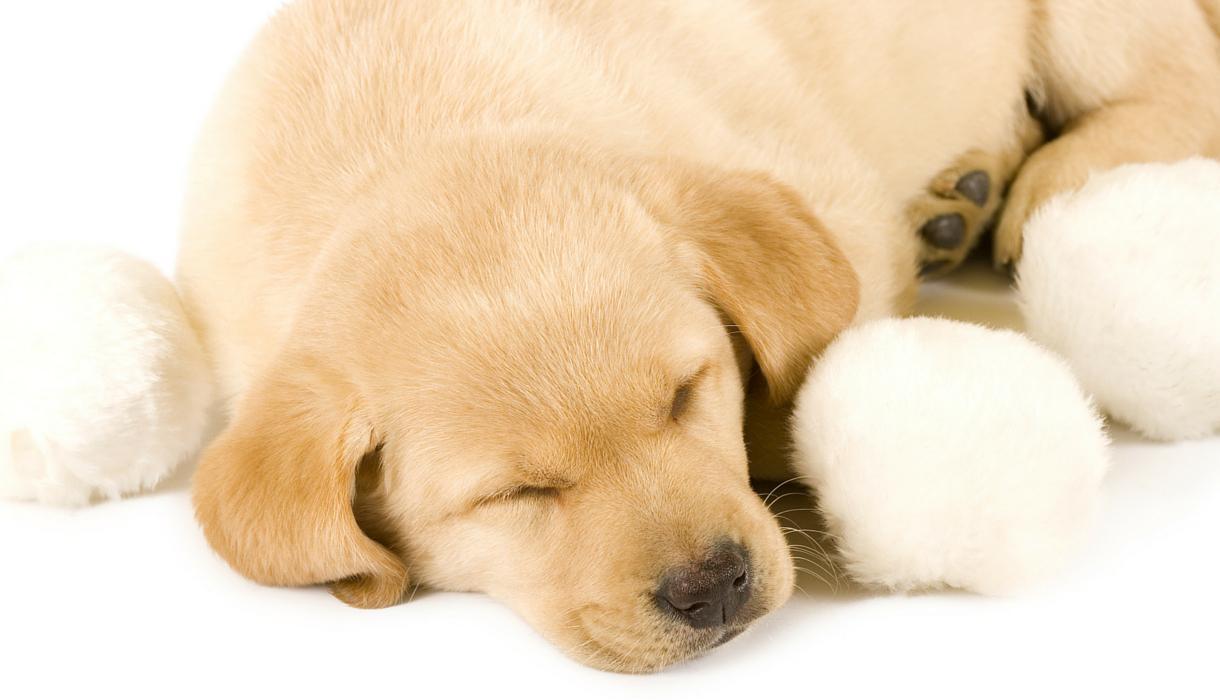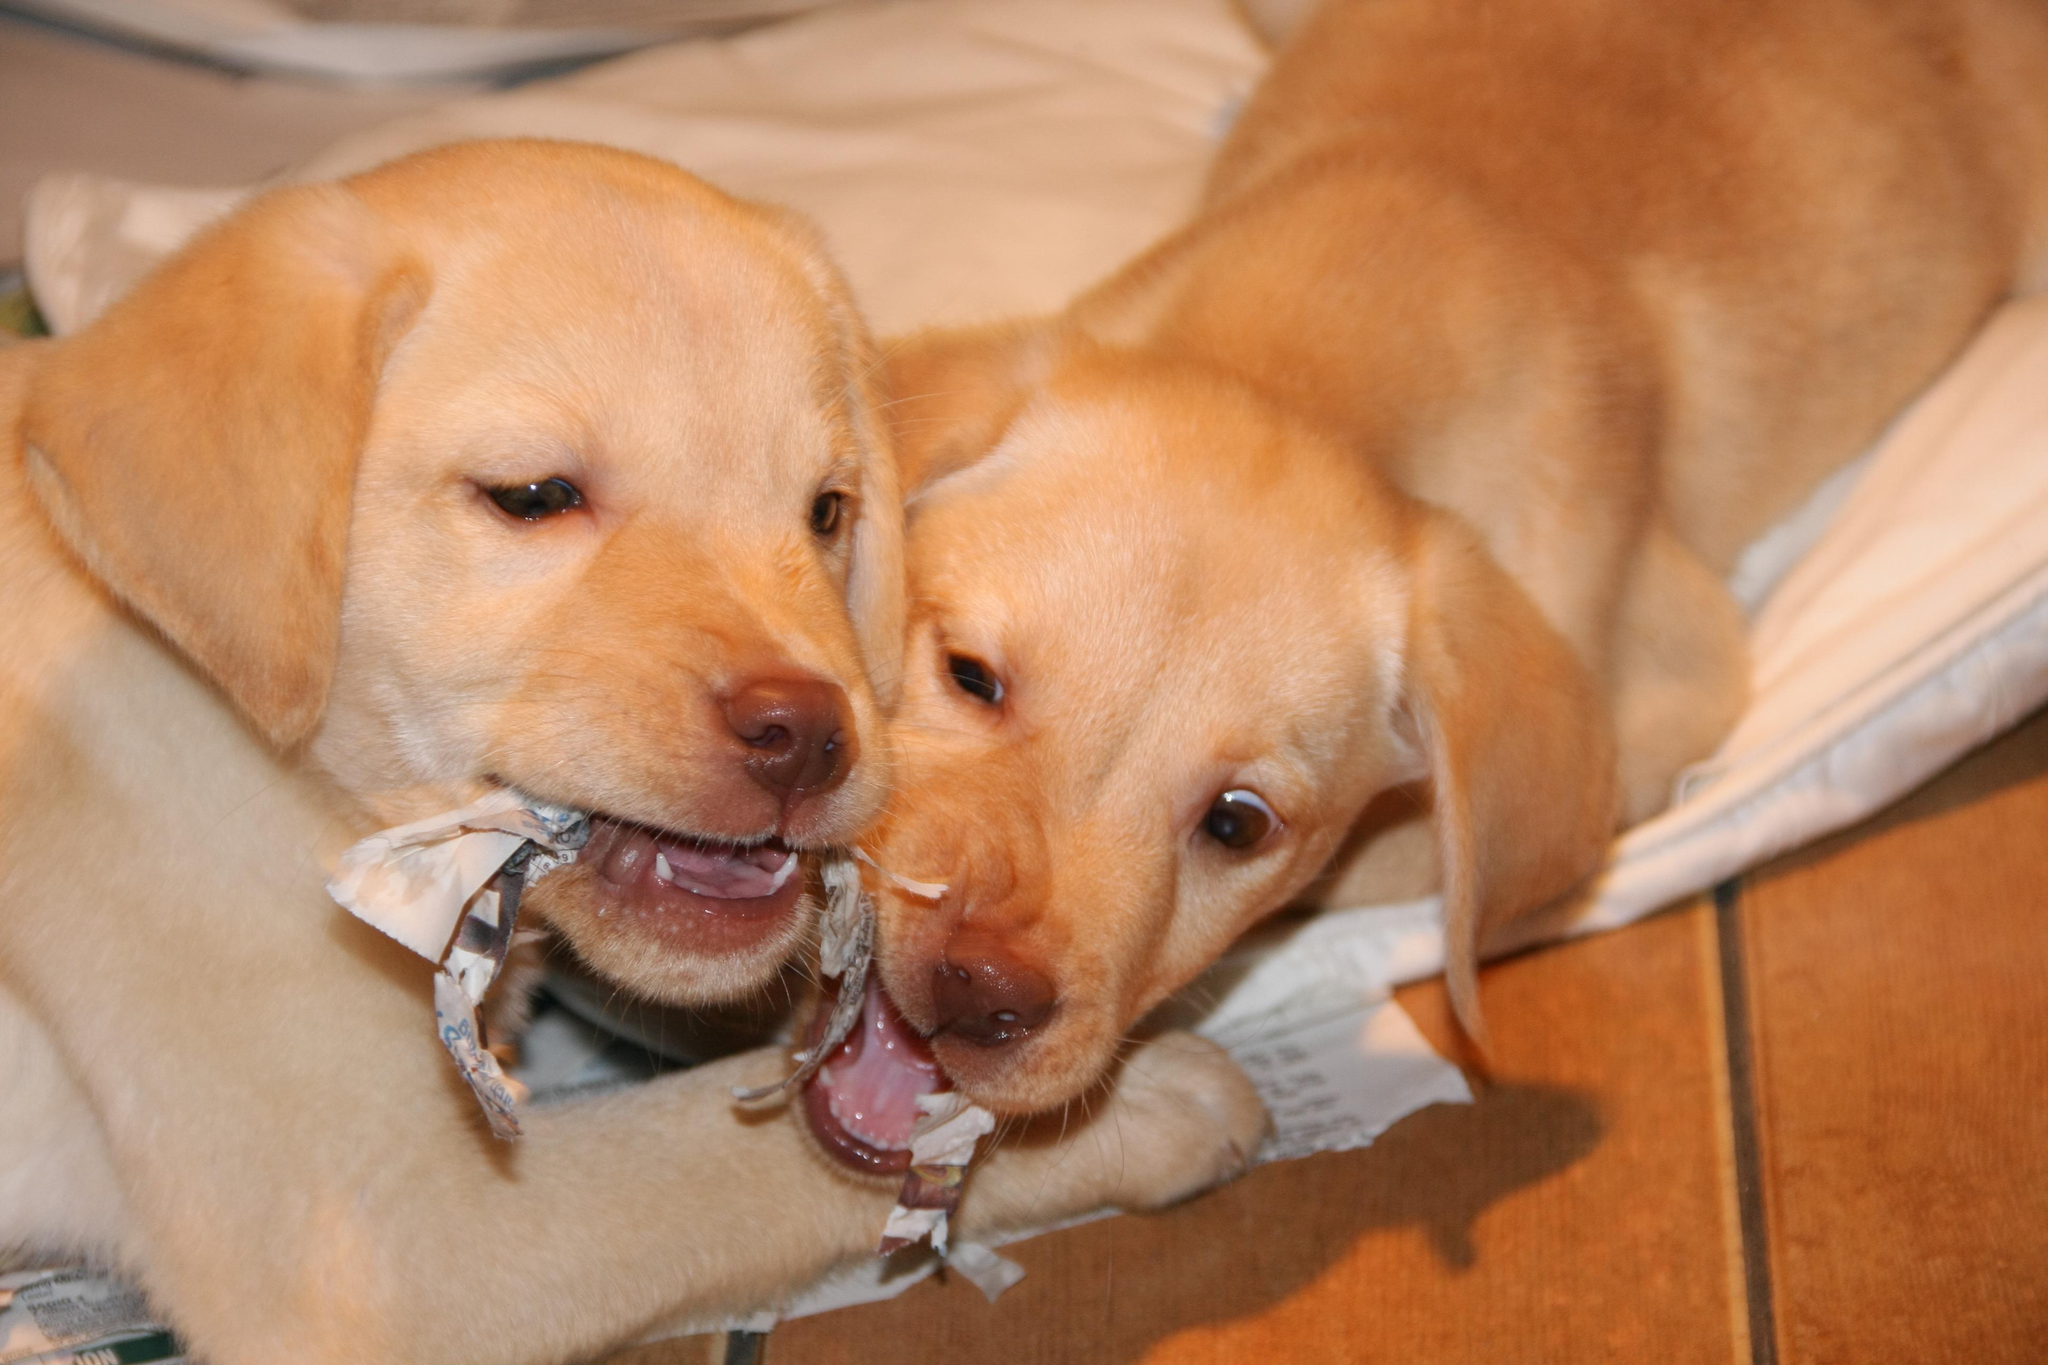The first image is the image on the left, the second image is the image on the right. For the images shown, is this caption "some dogs are sleeping and some are not." true? Answer yes or no. Yes. The first image is the image on the left, the second image is the image on the right. For the images shown, is this caption "Two dogs of similar coloring are snoozing with heads touching on a wood-grained surface." true? Answer yes or no. No. 